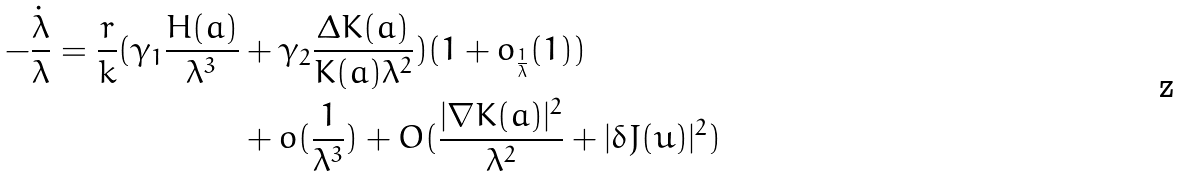<formula> <loc_0><loc_0><loc_500><loc_500>- \frac { \dot { \lambda } } { \lambda } = \frac { r } { k } ( \gamma _ { 1 } \frac { H ( a ) } { \lambda ^ { 3 } } & + \gamma _ { 2 } \frac { \Delta K ( a ) } { K ( a ) \lambda ^ { 2 } } ) ( 1 + o _ { \frac { 1 } { \lambda } } ( 1 ) ) \\ & + o ( \frac { 1 } { \lambda ^ { 3 } } ) + O ( \frac { | \nabla K ( a ) | ^ { 2 } } { \lambda ^ { 2 } } + | \delta J ( u ) | ^ { 2 } )</formula> 